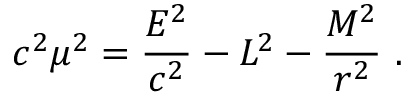<formula> <loc_0><loc_0><loc_500><loc_500>c ^ { 2 } \mu ^ { 2 } = { \frac { E ^ { 2 } } { c ^ { 2 } } } - L ^ { 2 } - { \frac { M ^ { 2 } } { r ^ { 2 } } } \ .</formula> 